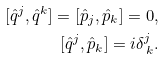<formula> <loc_0><loc_0><loc_500><loc_500>[ { \hat { q } } ^ { j } , { \hat { q } } ^ { k } ] = [ { \hat { p } } _ { j } , { \hat { p } } _ { k } ] = 0 , \\ [ { \hat { q } } ^ { j } , { \hat { p } } _ { k } ] = i { } \delta _ { \, k } ^ { j } .</formula> 